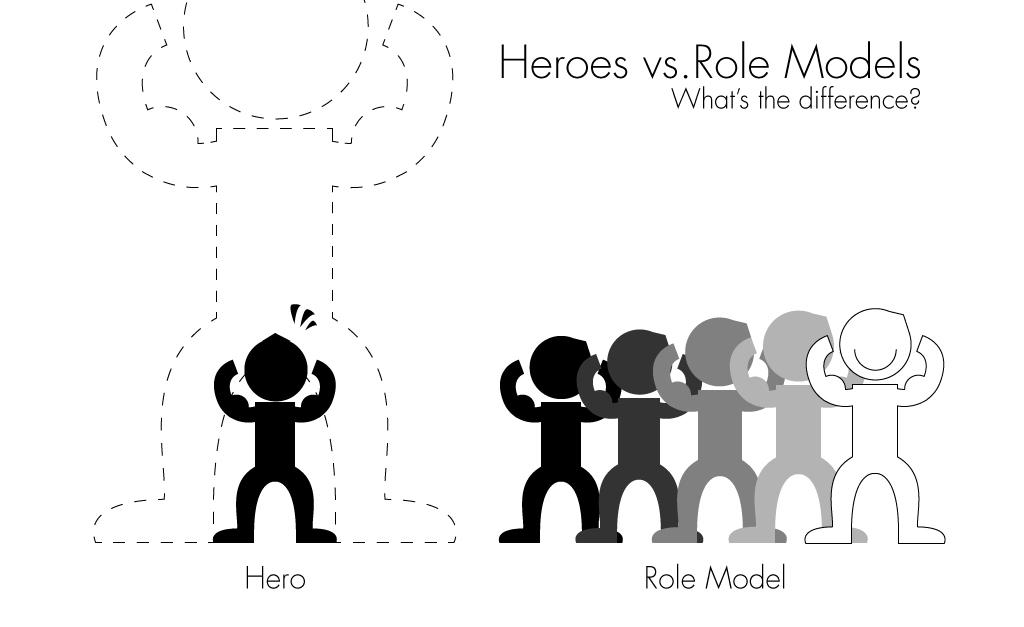What type of image is being described? The image is an animated picture. What can be seen in addition to the animation? There are words visible in the image. What kind of characters are present in the animated picture? There are icons of persons in the image. What decision does the laborer make in the image? There is no laborer present in the image, as it only contains icons of persons and not specific characters. 